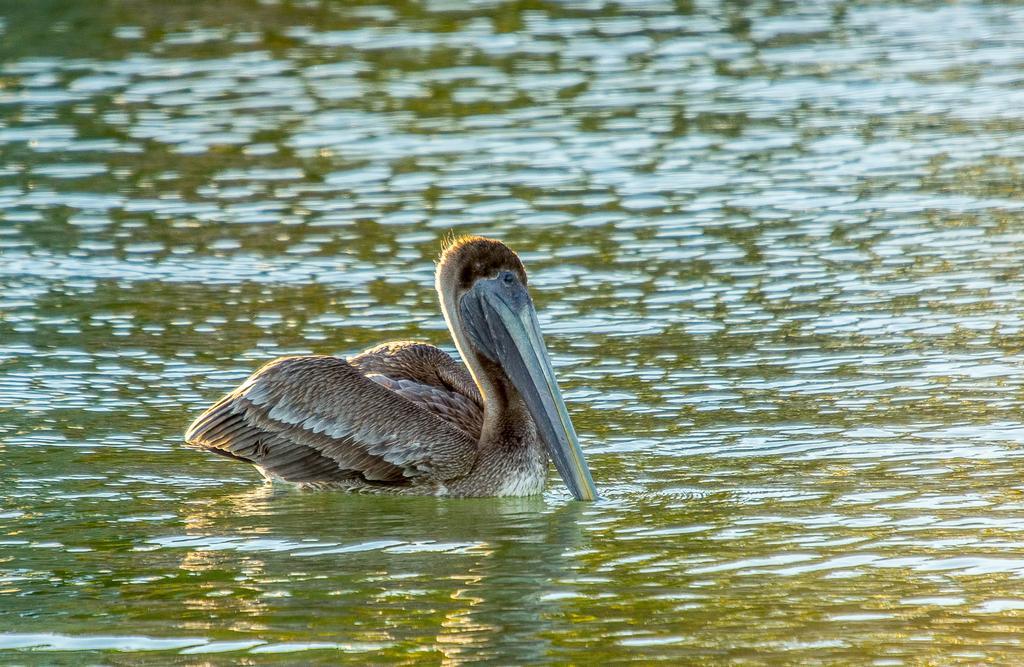In one or two sentences, can you explain what this image depicts? In this image we can see the bird on the water. 